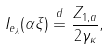Convert formula to latex. <formula><loc_0><loc_0><loc_500><loc_500>I _ { e _ { \lambda } } ( \alpha \xi ) \stackrel { d } { = } \frac { Z _ { 1 , a } } { 2 \gamma _ { \kappa } } ,</formula> 